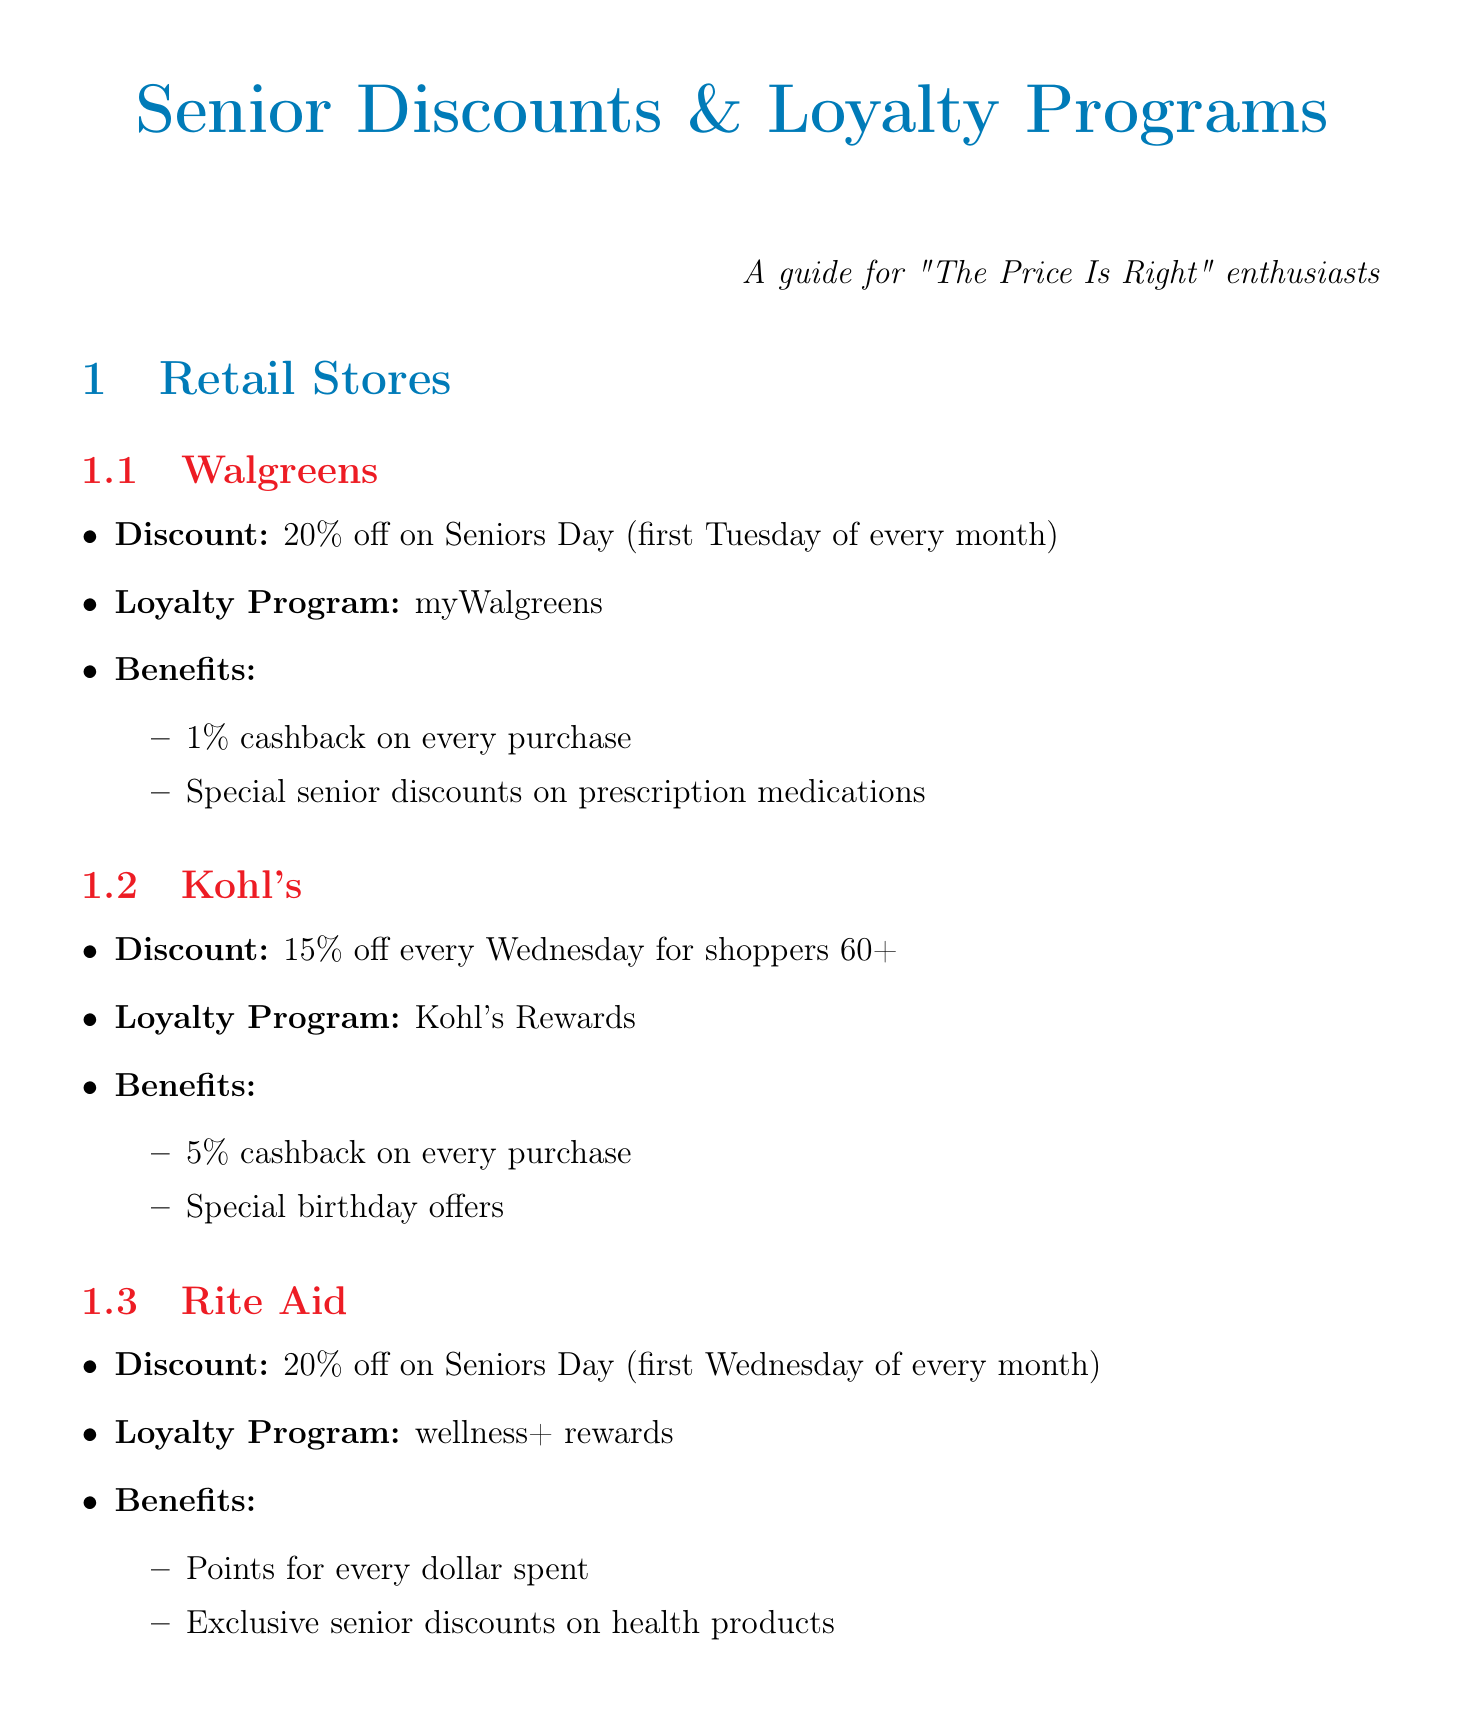What is the discount at Walgreens on Seniors Day? The document states that Walgreens offers a 20% discount on Seniors Day, which occurs on the first Tuesday of every month.
Answer: 20% off How much cashback does the myWalgreens loyalty program provide? According to the document, the myWalgreens program provides 1% cashback on every purchase.
Answer: 1% cashback What day does Kohl's offer a discount for seniors? The document mentions that Kohl's offers a 15% discount every Wednesday for shoppers 60+.
Answer: Wednesday What is the percentage range of the discount available at Applebee's? The document indicates that Applebee's offers a discount that varies from 10% to 15% for seniors 60+.
Answer: 10-15% Which travel company offers a discount for seniors aged 65 and older? The document specifies that Amtrak offers a 10% discount for seniors aged 65 and older.
Answer: Amtrak What special offer do seniors receive with Denny's Rewards? The document states that Denny's Rewards includes a free birthday meal for seniors.
Answer: Free birthday meal How do seniors benefit from the AMC Stubs loyalty program? The document lists that AMC Stubs offers free popcorn refills as part of its benefits for seniors.
Answer: Free popcorn refills What type of community involvement suggestion is made in the document? The document suggests organizing local "Price is Right" viewing parties for seniors to share discount information.
Answer: Organize viewing parties What is the specific discount day at Rite Aid for seniors? The document states that Rite Aid has a Seniors Day on the first Wednesday of every month where seniors can receive a discount.
Answer: First Wednesday of every month 